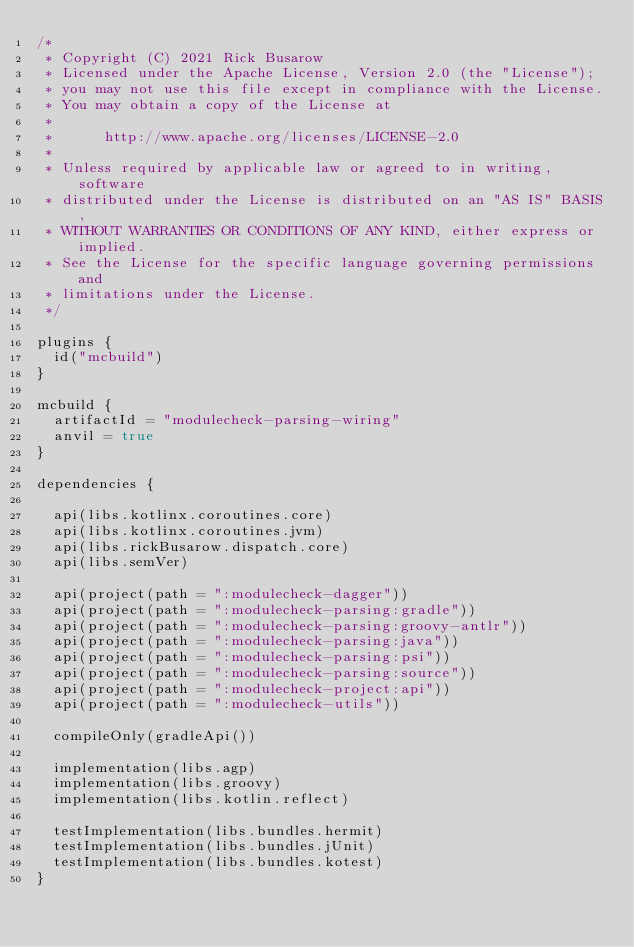<code> <loc_0><loc_0><loc_500><loc_500><_Kotlin_>/*
 * Copyright (C) 2021 Rick Busarow
 * Licensed under the Apache License, Version 2.0 (the "License");
 * you may not use this file except in compliance with the License.
 * You may obtain a copy of the License at
 *
 *      http://www.apache.org/licenses/LICENSE-2.0
 *
 * Unless required by applicable law or agreed to in writing, software
 * distributed under the License is distributed on an "AS IS" BASIS,
 * WITHOUT WARRANTIES OR CONDITIONS OF ANY KIND, either express or implied.
 * See the License for the specific language governing permissions and
 * limitations under the License.
 */

plugins {
  id("mcbuild")
}

mcbuild {
  artifactId = "modulecheck-parsing-wiring"
  anvil = true
}

dependencies {

  api(libs.kotlinx.coroutines.core)
  api(libs.kotlinx.coroutines.jvm)
  api(libs.rickBusarow.dispatch.core)
  api(libs.semVer)

  api(project(path = ":modulecheck-dagger"))
  api(project(path = ":modulecheck-parsing:gradle"))
  api(project(path = ":modulecheck-parsing:groovy-antlr"))
  api(project(path = ":modulecheck-parsing:java"))
  api(project(path = ":modulecheck-parsing:psi"))
  api(project(path = ":modulecheck-parsing:source"))
  api(project(path = ":modulecheck-project:api"))
  api(project(path = ":modulecheck-utils"))

  compileOnly(gradleApi())

  implementation(libs.agp)
  implementation(libs.groovy)
  implementation(libs.kotlin.reflect)

  testImplementation(libs.bundles.hermit)
  testImplementation(libs.bundles.jUnit)
  testImplementation(libs.bundles.kotest)
}
</code> 